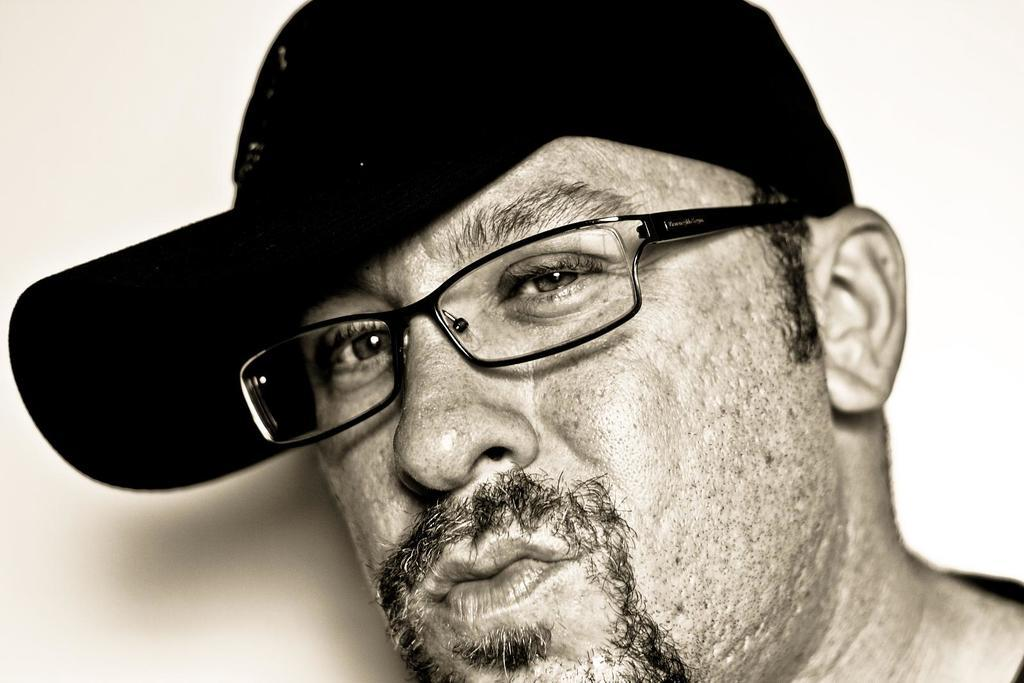What is the main subject of the image? There is a person in the image. Can you describe the person's appearance? The person is wearing spectacles and a cap. What type of spy equipment can be seen in the person's hands in the image? There is no spy equipment visible in the person's hands in the image. Who is the person's partner in the image? There is no indication of a partner or any other person in the image. 